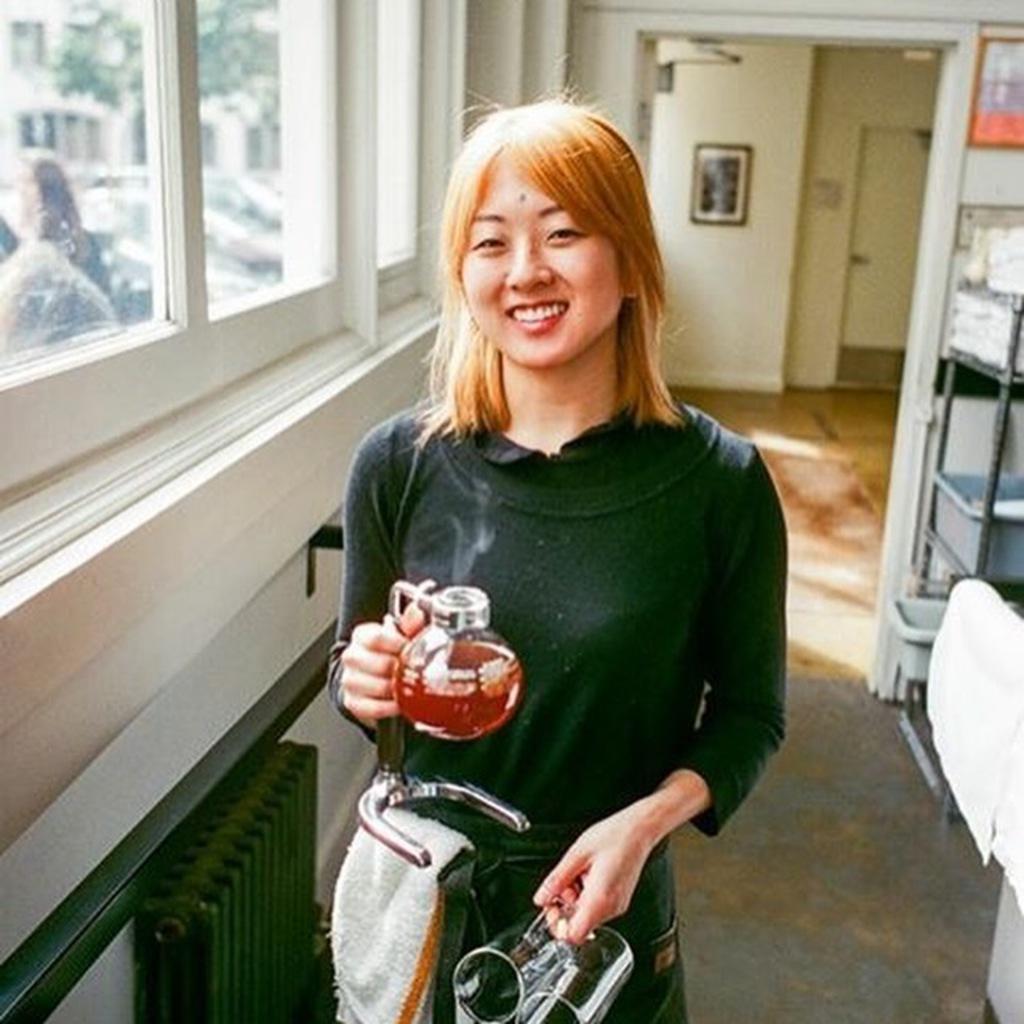Can you describe this image briefly? In this image in front there is a person standing by holding the jars. Beside her there are glass windows. On the right side of the image there is a rack with the objects in it. On the backside there is a wall with the photo frame on it. At the bottom of the image there is a floor. 